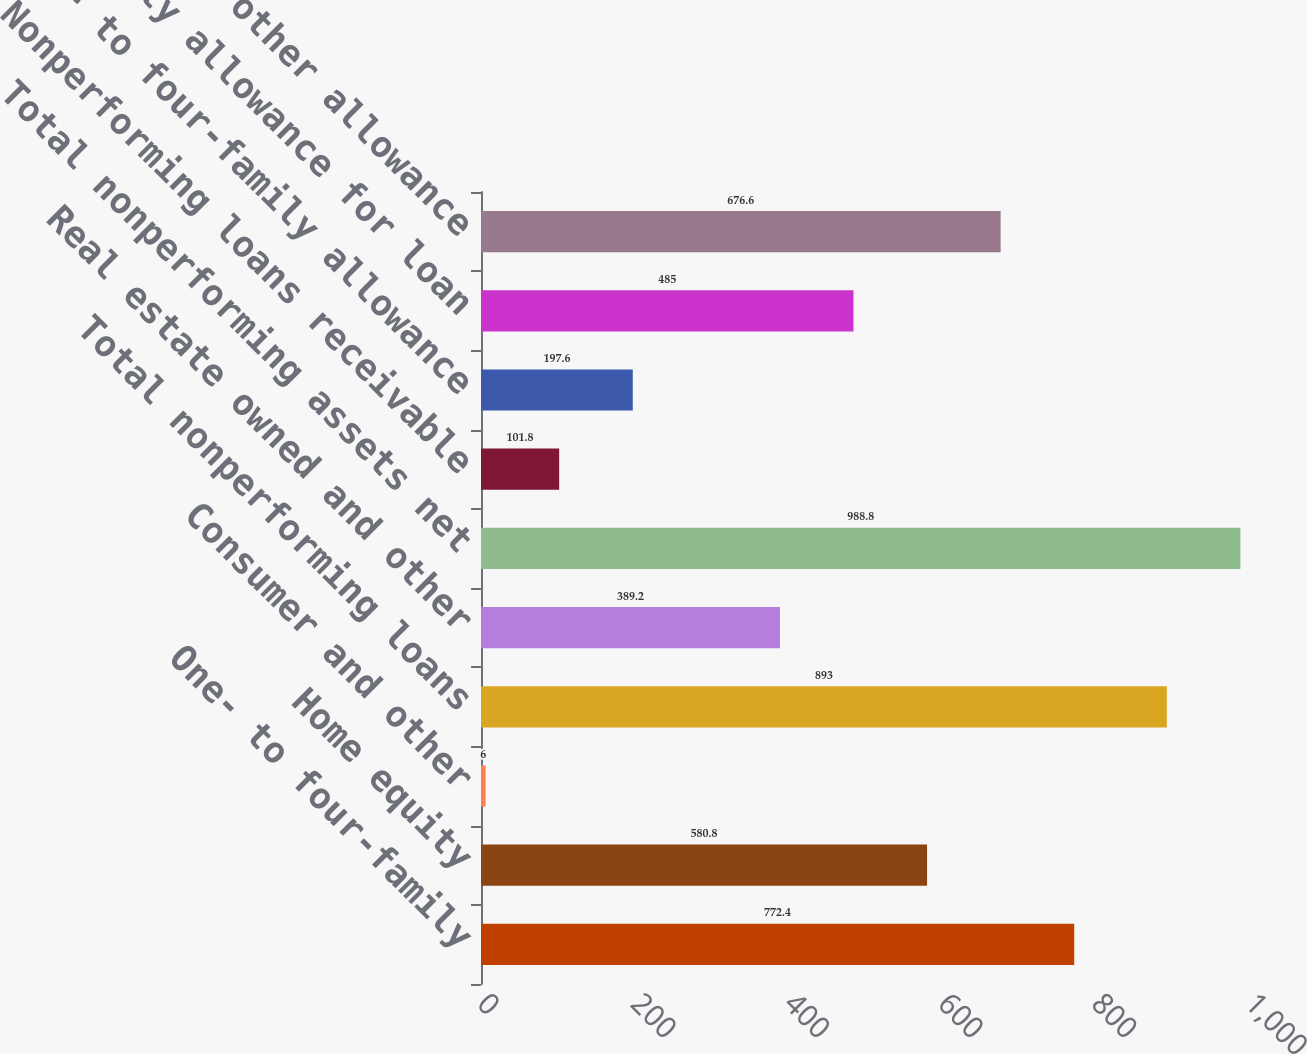<chart> <loc_0><loc_0><loc_500><loc_500><bar_chart><fcel>One- to four-family<fcel>Home equity<fcel>Consumer and other<fcel>Total nonperforming loans<fcel>Real estate owned and other<fcel>Total nonperforming assets net<fcel>Nonperforming loans receivable<fcel>One- to four-family allowance<fcel>Home equity allowance for loan<fcel>Consumer and other allowance<nl><fcel>772.4<fcel>580.8<fcel>6<fcel>893<fcel>389.2<fcel>988.8<fcel>101.8<fcel>197.6<fcel>485<fcel>676.6<nl></chart> 